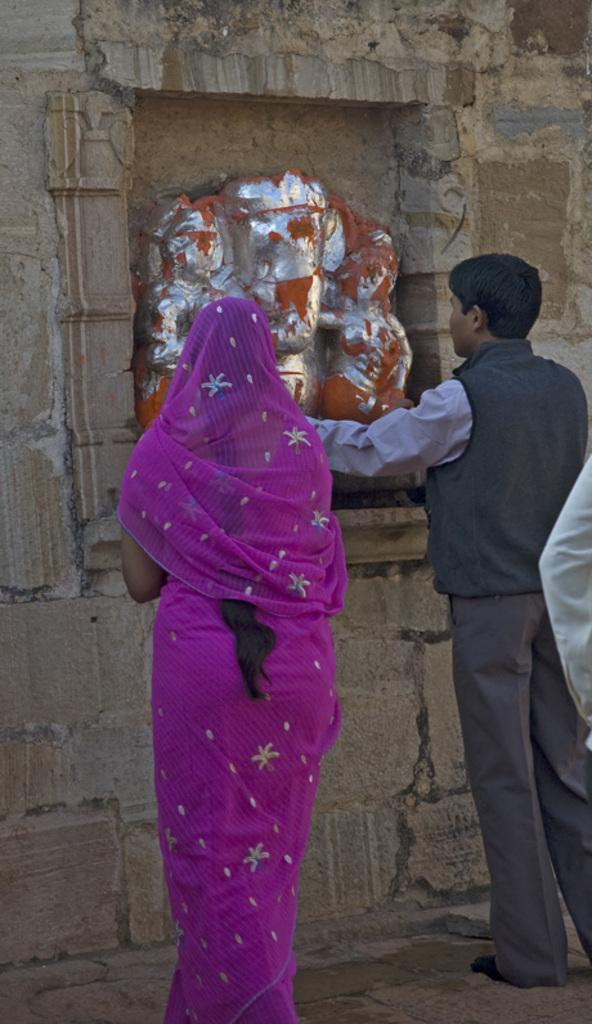What is the main subject in the picture? There is an idol in the picture. Are there any other elements present in the image? Yes, there are people standing in the picture. What type of haircut does the writer have in the image? There is no writer present in the image, and therefore no haircut can be observed. 